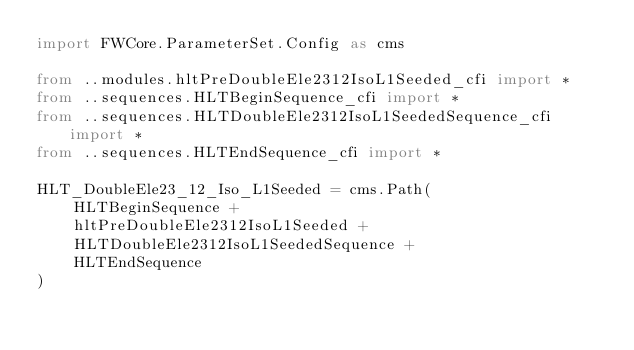<code> <loc_0><loc_0><loc_500><loc_500><_Python_>import FWCore.ParameterSet.Config as cms

from ..modules.hltPreDoubleEle2312IsoL1Seeded_cfi import *
from ..sequences.HLTBeginSequence_cfi import *
from ..sequences.HLTDoubleEle2312IsoL1SeededSequence_cfi import *
from ..sequences.HLTEndSequence_cfi import *

HLT_DoubleEle23_12_Iso_L1Seeded = cms.Path(
    HLTBeginSequence +
    hltPreDoubleEle2312IsoL1Seeded +
    HLTDoubleEle2312IsoL1SeededSequence +
    HLTEndSequence
)
</code> 